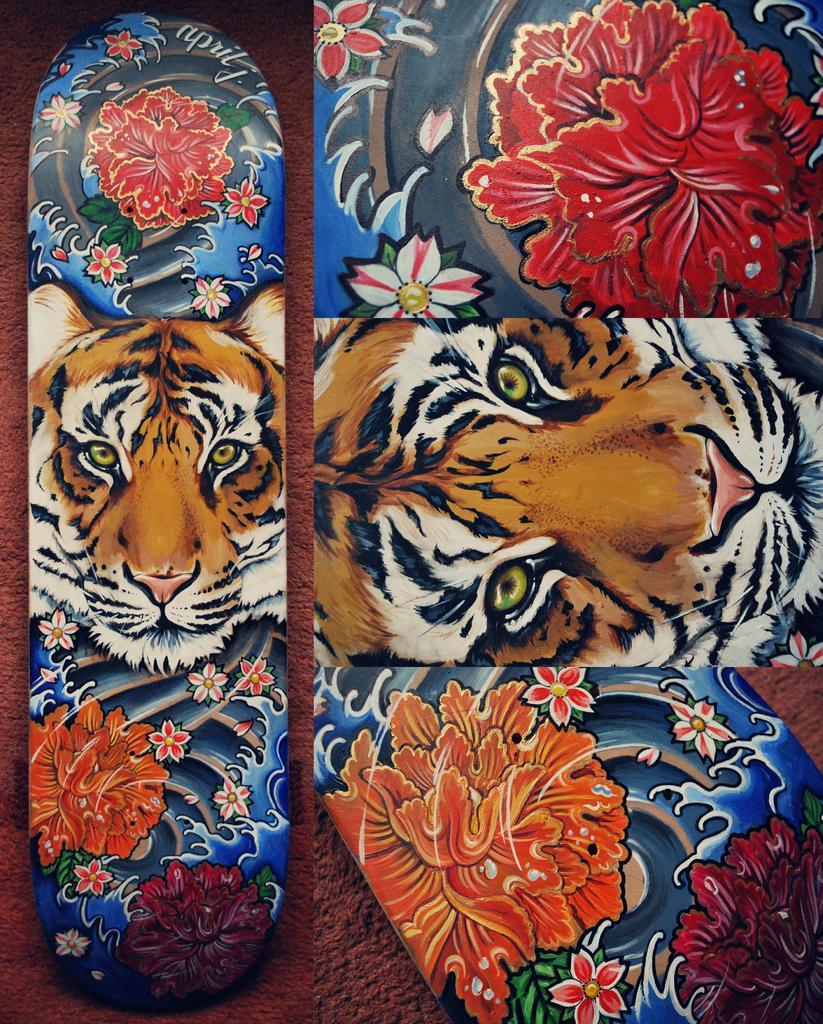How would you summarize this image in a sentence or two? The picture consists of skateboards, on the skateboards there are floral designs and tiger. 